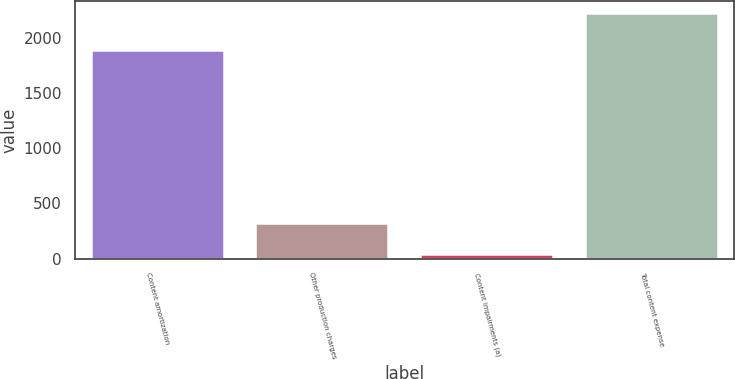Convert chart. <chart><loc_0><loc_0><loc_500><loc_500><bar_chart><fcel>Content amortization<fcel>Other production charges<fcel>Content impairments (a)<fcel>Total content expense<nl><fcel>1878<fcel>310<fcel>32<fcel>2220<nl></chart> 